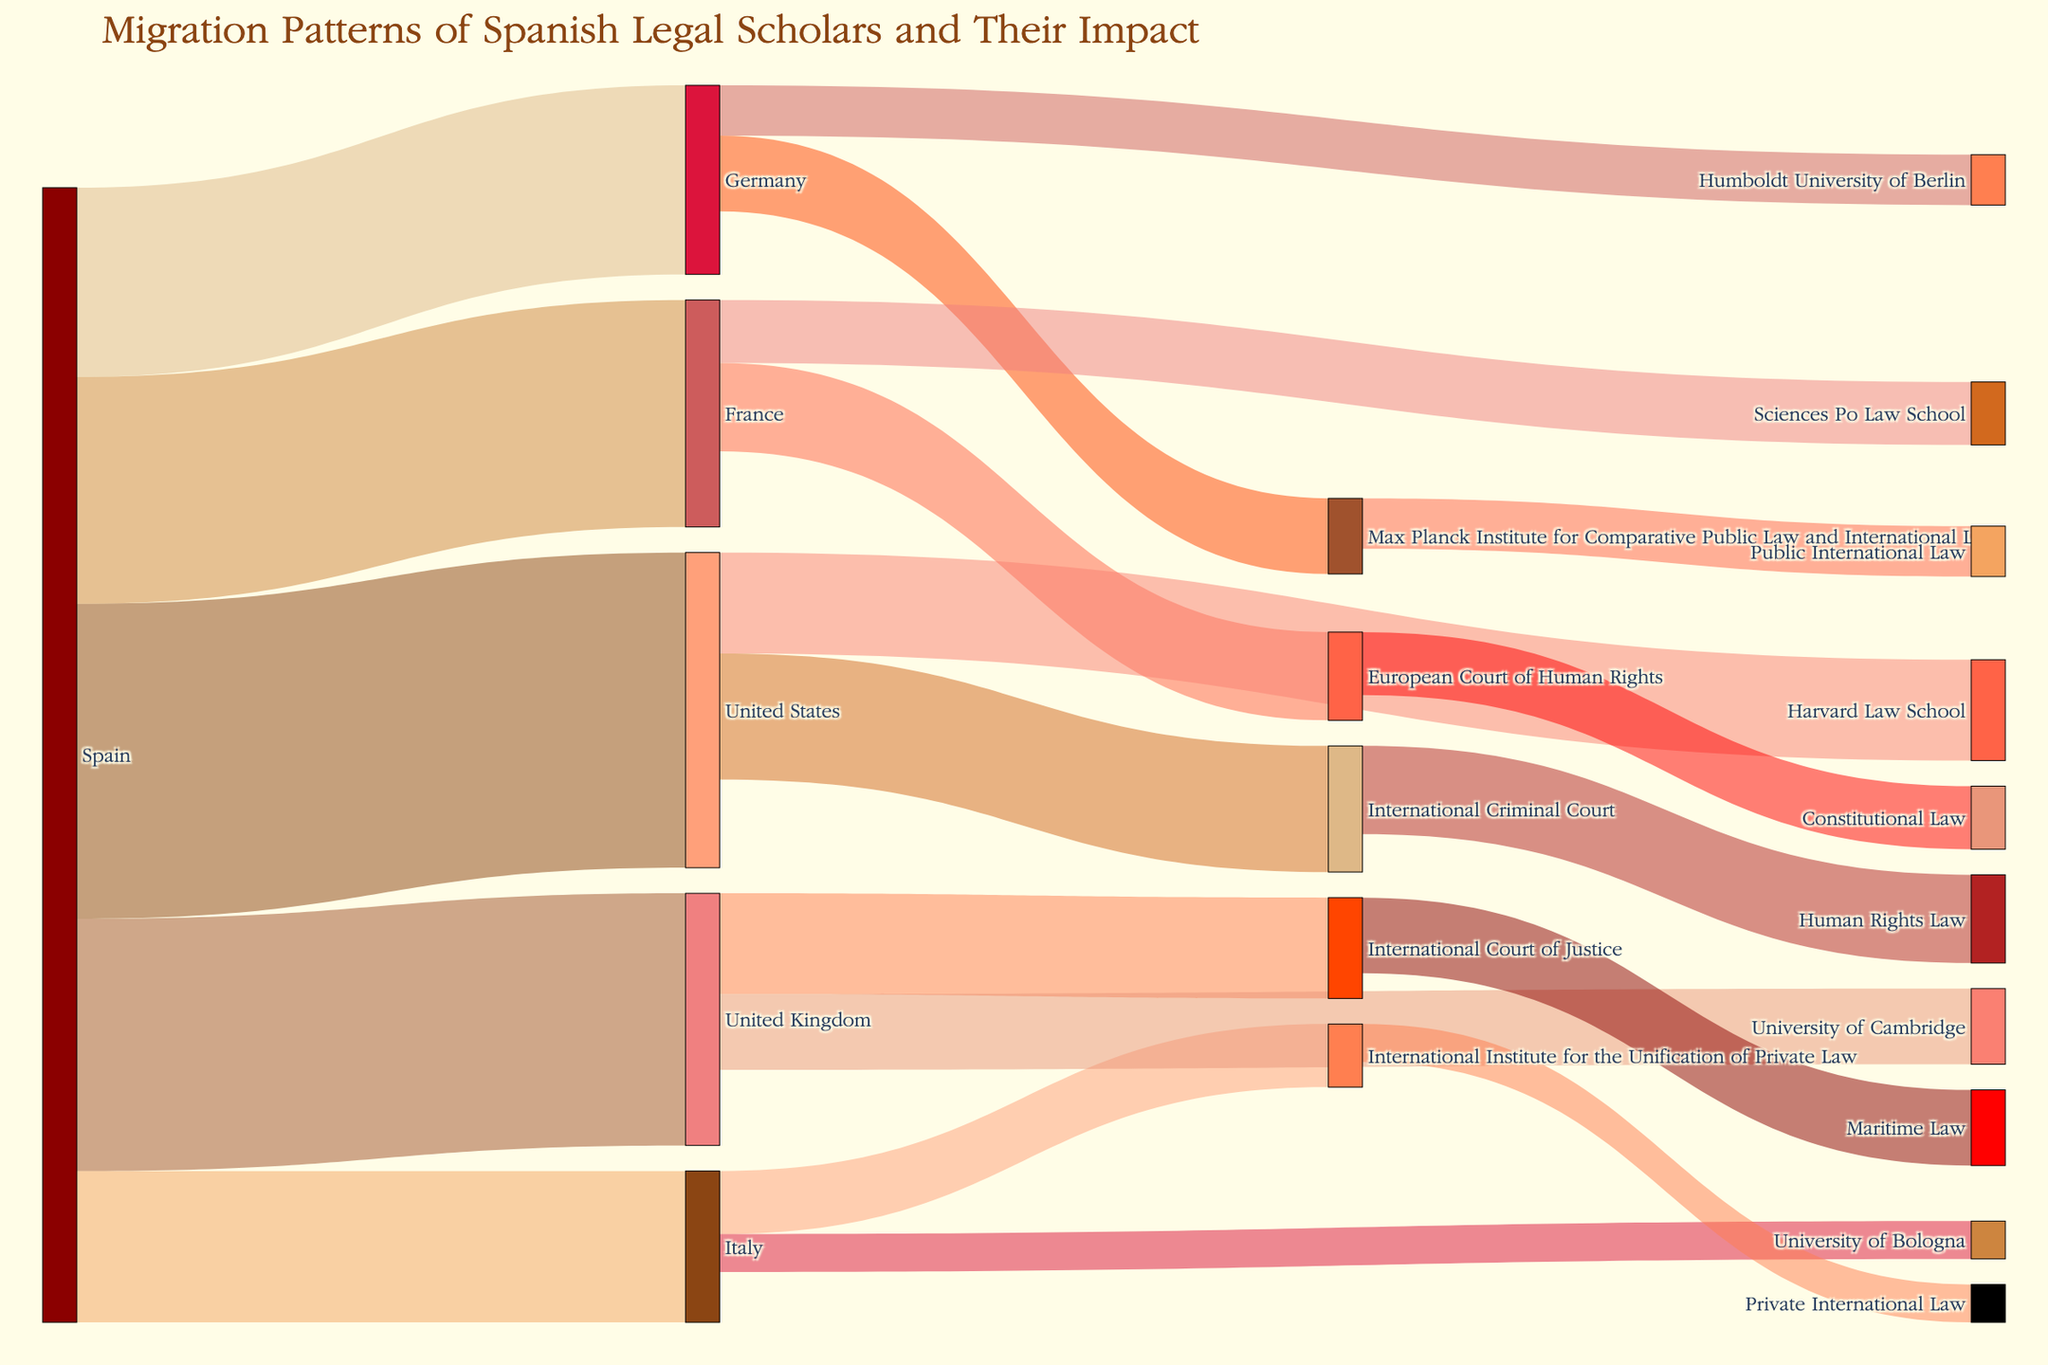What is the title of the Sankey diagram? The title is often placed at the top of the diagram and typically summarized in few words. Here, the title, as per the description, is about migration patterns and impact of Spanish legal scholars.
Answer: Migration Patterns of Spanish Legal Scholars and Their Impact Which country received the highest number of Spanish legal scholars? To determine this, look for the source labeled "Spain" and check the target with the highest value in connections originating from it.
Answer: United States Which institution in the United States hosted the highest number of Spanish legal scholars? First, identify the links going from the United States to other targets, then find the one with the highest value.
Answer: Harvard Law School How many Spanish legal scholars migrated to European countries (France, Germany, Italy, United Kingdom) combined? Add up the values for these countries: Spain to France (18), Spain to Germany (15), Spain to Italy (12), and Spain to United Kingdom (20). The total is 18 + 15 + 12 + 20.
Answer: 65 Which institution contributed most to Human Rights Law? Look for the target "Human Rights Law" and check the source with the highest value in connections leading to it.
Answer: International Criminal Court Which field of law is associated with the European Court of Human Rights? Look at the link from the European Court of Human Rights and see the field it is connected to.
Answer: Constitutional Law Compare the number of scholars moving to the International Criminal Court and the International Court of Justice. Which is higher and by how much? Identify the values leading to both courts: ICC (10) and ICJ (8). Calculate the difference.
Answer: ICC is higher by 2 scholars What is the combined total number of scholars in the fields of Public International Law and Private International Law? Add the values for these fields: Public International Law (4) from Max Planck Institute and Private International Law (3) from International Institute. The total is 4 + 3.
Answer: 7 Which two institutions in France received Spanish legal scholars and what are the respective numbers for each? Identify the targets in France and their corresponding values: Sciences Po Law School (5) and European Court of Human Rights (7).
Answer: Sciences Po Law School: 5, European Court of Human Rights: 7 How does the number of scholars at the International Institute for the Unification of Private Law compare to those at the University of Bologna? Look for the values connected to each: International Institute (5) and University of Bologna (3). Compare these values.
Answer: International Institute has 2 more scholars than University of Bologna 